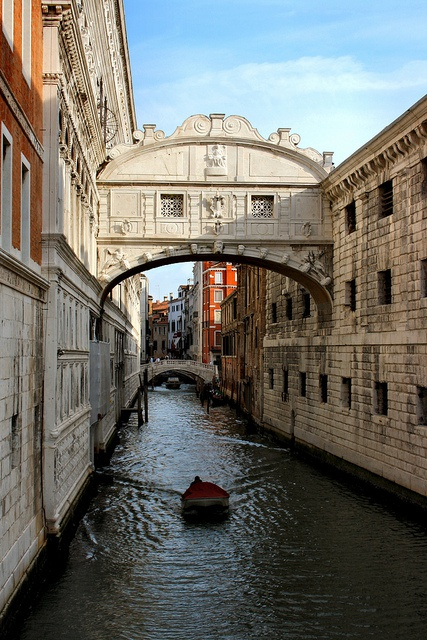Describe the objects in this image and their specific colors. I can see boat in red, black, maroon, and gray tones and boat in red, black, and gray tones in this image. 